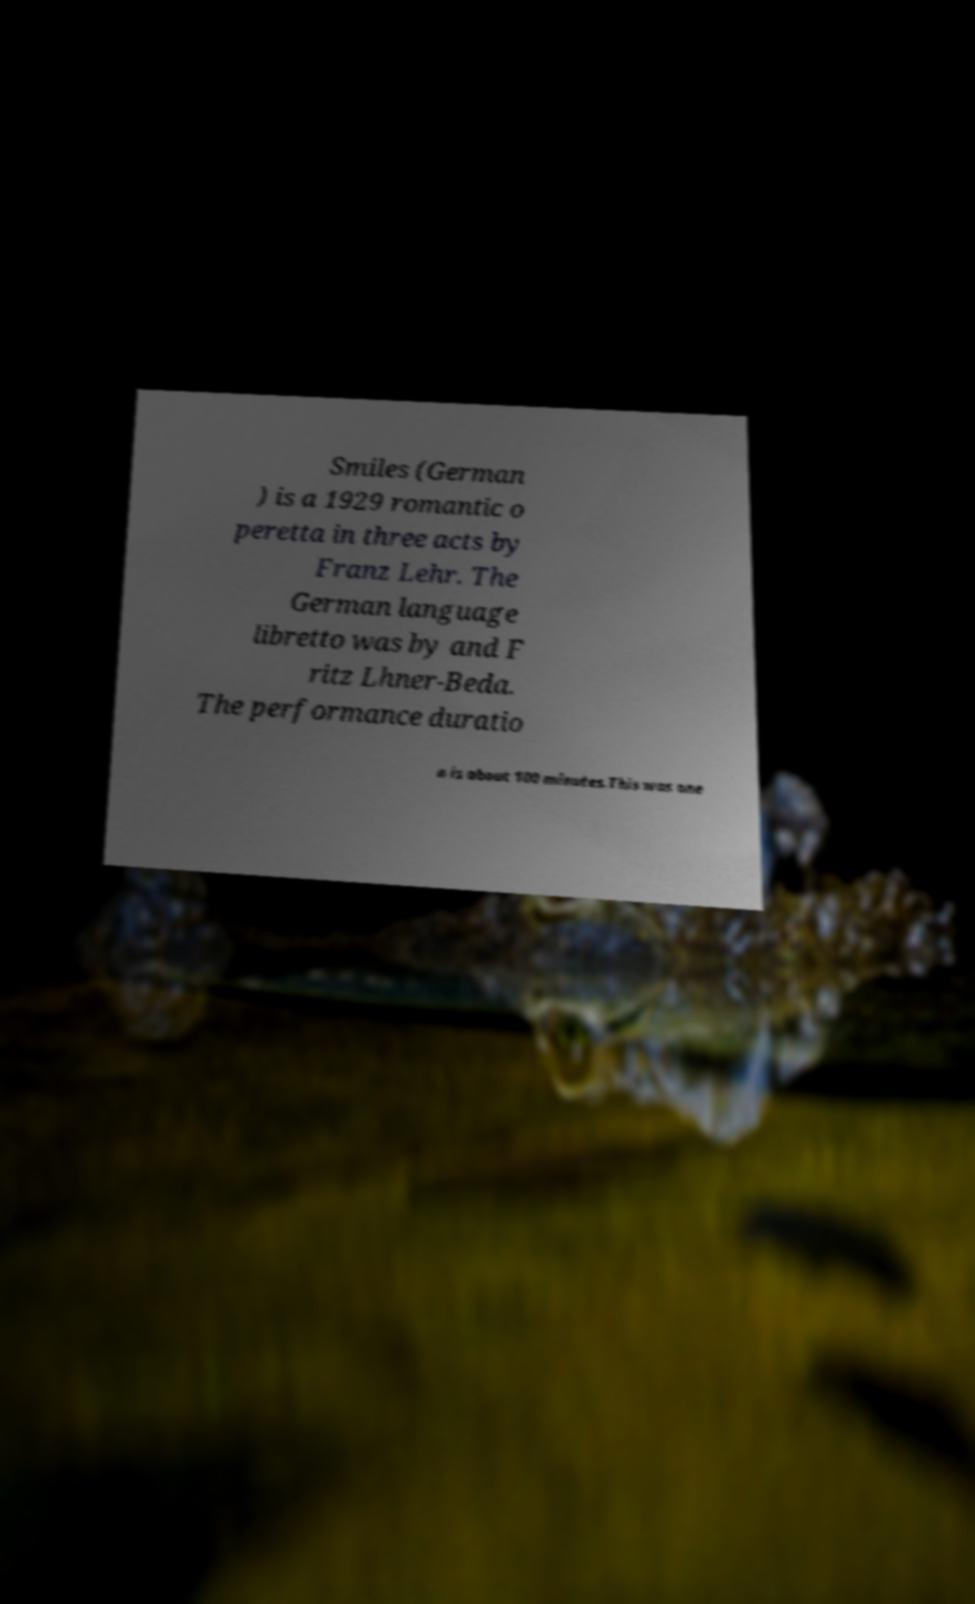Please identify and transcribe the text found in this image. Smiles (German ) is a 1929 romantic o peretta in three acts by Franz Lehr. The German language libretto was by and F ritz Lhner-Beda. The performance duratio n is about 100 minutes.This was one 